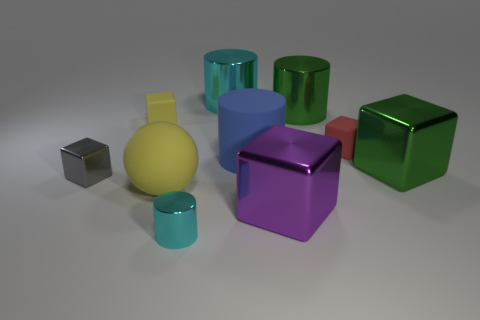Subtract all big green shiny blocks. How many blocks are left? 4 Add 3 cyan things. How many cyan things are left? 5 Add 6 large brown rubber balls. How many large brown rubber balls exist? 6 Subtract all yellow blocks. How many blocks are left? 4 Subtract 1 green blocks. How many objects are left? 9 Subtract all balls. How many objects are left? 9 Subtract 3 cubes. How many cubes are left? 2 Subtract all purple cylinders. Subtract all gray spheres. How many cylinders are left? 4 Subtract all blue balls. How many gray cubes are left? 1 Subtract all big green shiny cubes. Subtract all yellow rubber balls. How many objects are left? 8 